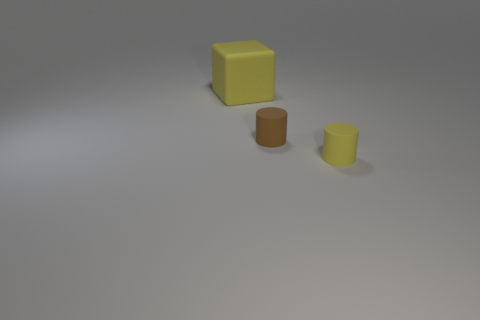Is there anything else that has the same shape as the large matte object?
Keep it short and to the point. No. There is a yellow rubber object that is behind the brown cylinder; are there any small matte cylinders that are on the right side of it?
Your response must be concise. Yes. There is a matte block; are there any things on the right side of it?
Your response must be concise. Yes. Are there the same number of things that are in front of the brown cylinder and yellow rubber things that are in front of the big thing?
Provide a succinct answer. Yes. How many small brown spheres are there?
Offer a very short reply. 0. Are there more tiny rubber cylinders that are to the left of the yellow rubber cylinder than blue metal blocks?
Provide a succinct answer. Yes. The other thing that is the same shape as the brown matte thing is what color?
Your response must be concise. Yellow. What number of rubber cylinders are the same color as the big block?
Offer a terse response. 1. There is a yellow object in front of the large block; is it the same size as the yellow rubber thing that is behind the small yellow thing?
Keep it short and to the point. No. Do the brown matte cylinder and the yellow matte object behind the brown matte cylinder have the same size?
Ensure brevity in your answer.  No. 